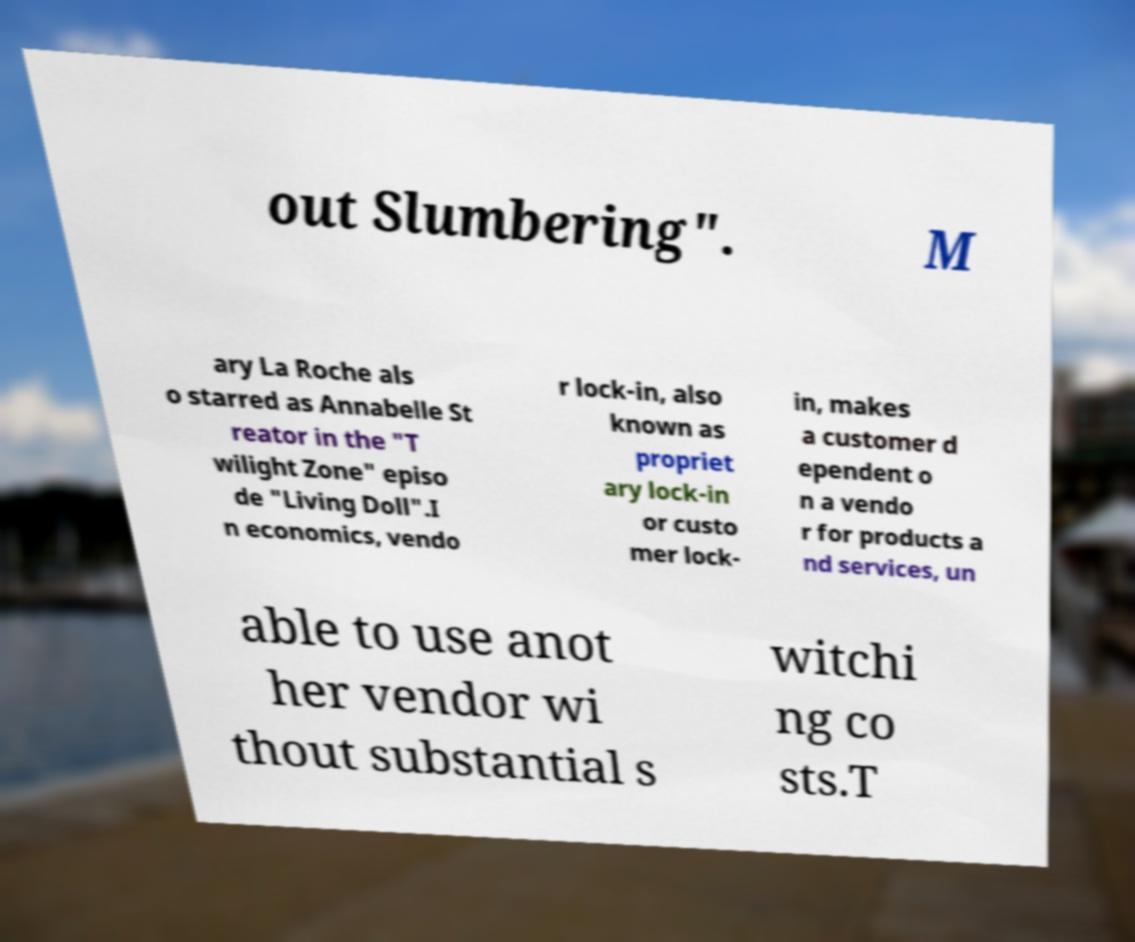Please read and relay the text visible in this image. What does it say? out Slumbering". M ary La Roche als o starred as Annabelle St reator in the "T wilight Zone" episo de "Living Doll".I n economics, vendo r lock-in, also known as propriet ary lock-in or custo mer lock- in, makes a customer d ependent o n a vendo r for products a nd services, un able to use anot her vendor wi thout substantial s witchi ng co sts.T 